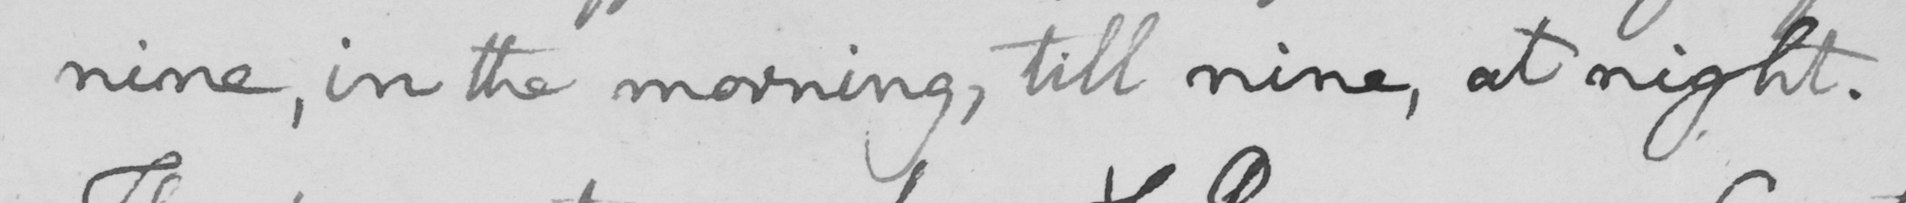Can you tell me what this handwritten text says? nine, in the morning, till nine, at night. 